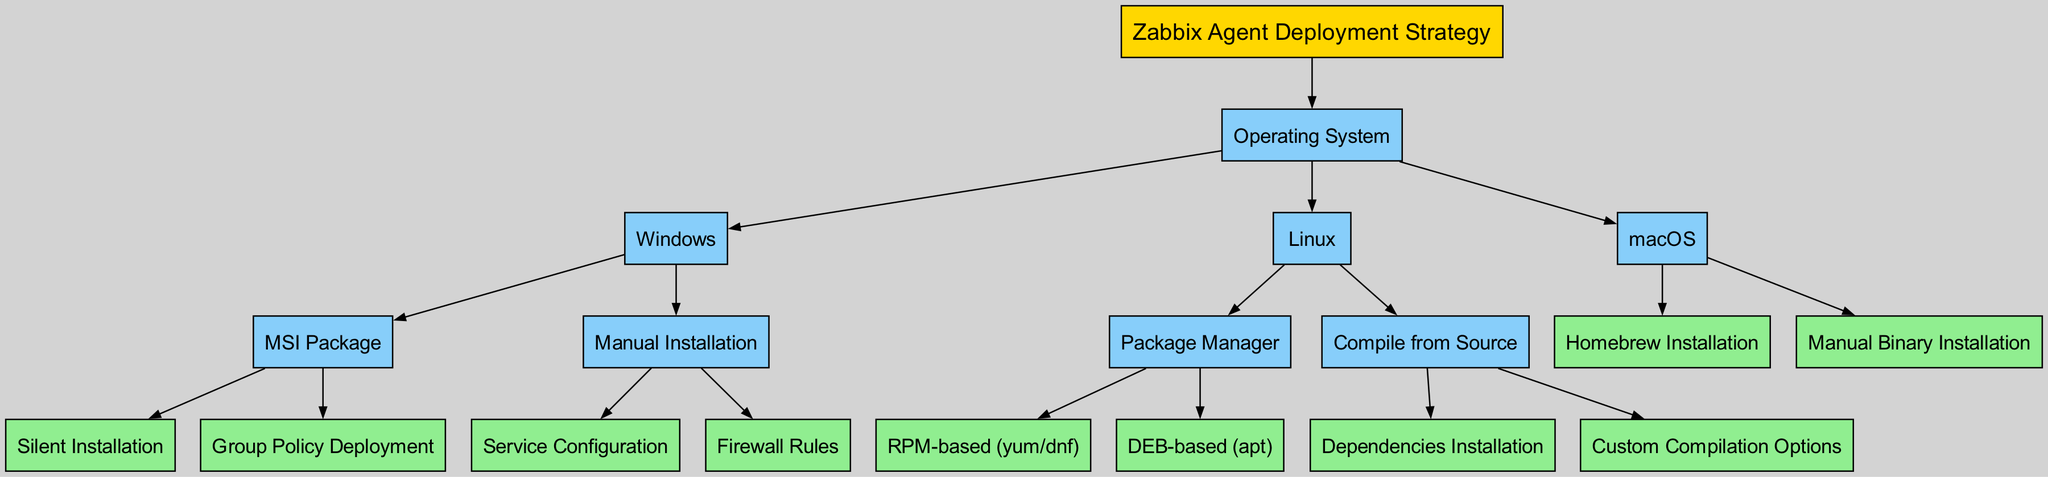What is the root of the decision tree? The root of the decision tree is labeled "Zabbix Agent Deployment Strategy." This is the topmost node from which all other nodes derive.
Answer: Zabbix Agent Deployment Strategy How many main operating systems are listed in the diagram? The diagram lists three main operating systems: Windows, Linux, and macOS. These are the first level of child nodes under the "Operating System" node.
Answer: 3 What is one deployment method for Windows? One deployment method for Windows is "MSI Package." It is one of the child nodes under the "Windows" node in the decision tree.
Answer: MSI Package Which deployment method under Linux requires the installation of dependencies? The method that requires the installation of dependencies is "Compile from Source," which has "Dependencies Installation" as one of its child nodes.
Answer: Compile from Source How many edges connect the "Operating System" node to its children? The "Operating System" node has three child nodes (Windows, Linux, macOS), resulting in three edges connecting it to those children.
Answer: 3 What two options are available for macOS installation? The two options for macOS installation are "Homebrew Installation" and "Manual Binary Installation." Each is a child node under the "macOS" node.
Answer: Homebrew Installation, Manual Binary Installation Which method involves group policy deployment for Windows agents? The method that involves group policy deployment for Windows agents is "Group Policy Deployment," which is a child under the "MSI Package" node.
Answer: Group Policy Deployment In the Linux section, what is the method used for package management in RPM-based systems? The method used for package management in RPM-based systems is "RPM-based (yum/dnf)," which is a child node under the "Package Manager" node in the Linux section.
Answer: RPM-based (yum/dnf) What is the last node in the Windows section of the decision tree? The last node in the Windows section is "Firewall Rules," which is a child of the "Manual Installation" node.
Answer: Firewall Rules 